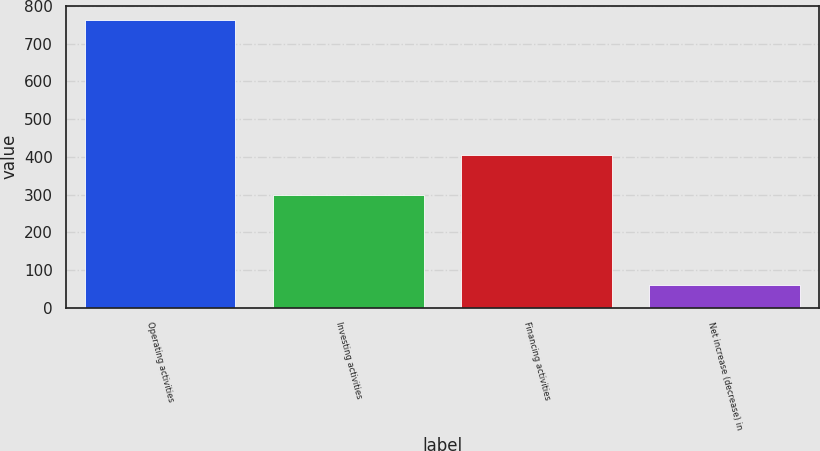Convert chart. <chart><loc_0><loc_0><loc_500><loc_500><bar_chart><fcel>Operating activities<fcel>Investing activities<fcel>Financing activities<fcel>Net increase (decrease) in<nl><fcel>762.6<fcel>298.1<fcel>405.2<fcel>59.3<nl></chart> 